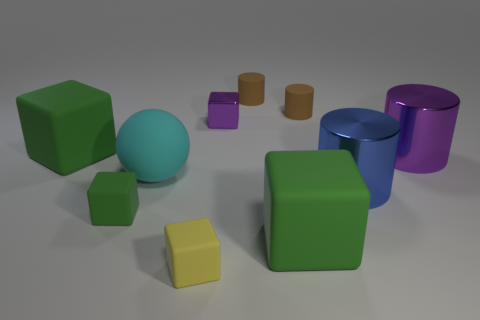Subtract all blue cylinders. How many green cubes are left? 3 Subtract all purple cubes. How many cubes are left? 4 Subtract 1 cylinders. How many cylinders are left? 3 Subtract all purple blocks. How many blocks are left? 4 Subtract all yellow cylinders. Subtract all green balls. How many cylinders are left? 4 Subtract all cylinders. How many objects are left? 6 Subtract 0 yellow cylinders. How many objects are left? 10 Subtract all small things. Subtract all small brown things. How many objects are left? 3 Add 3 tiny purple shiny blocks. How many tiny purple shiny blocks are left? 4 Add 8 big purple shiny cylinders. How many big purple shiny cylinders exist? 9 